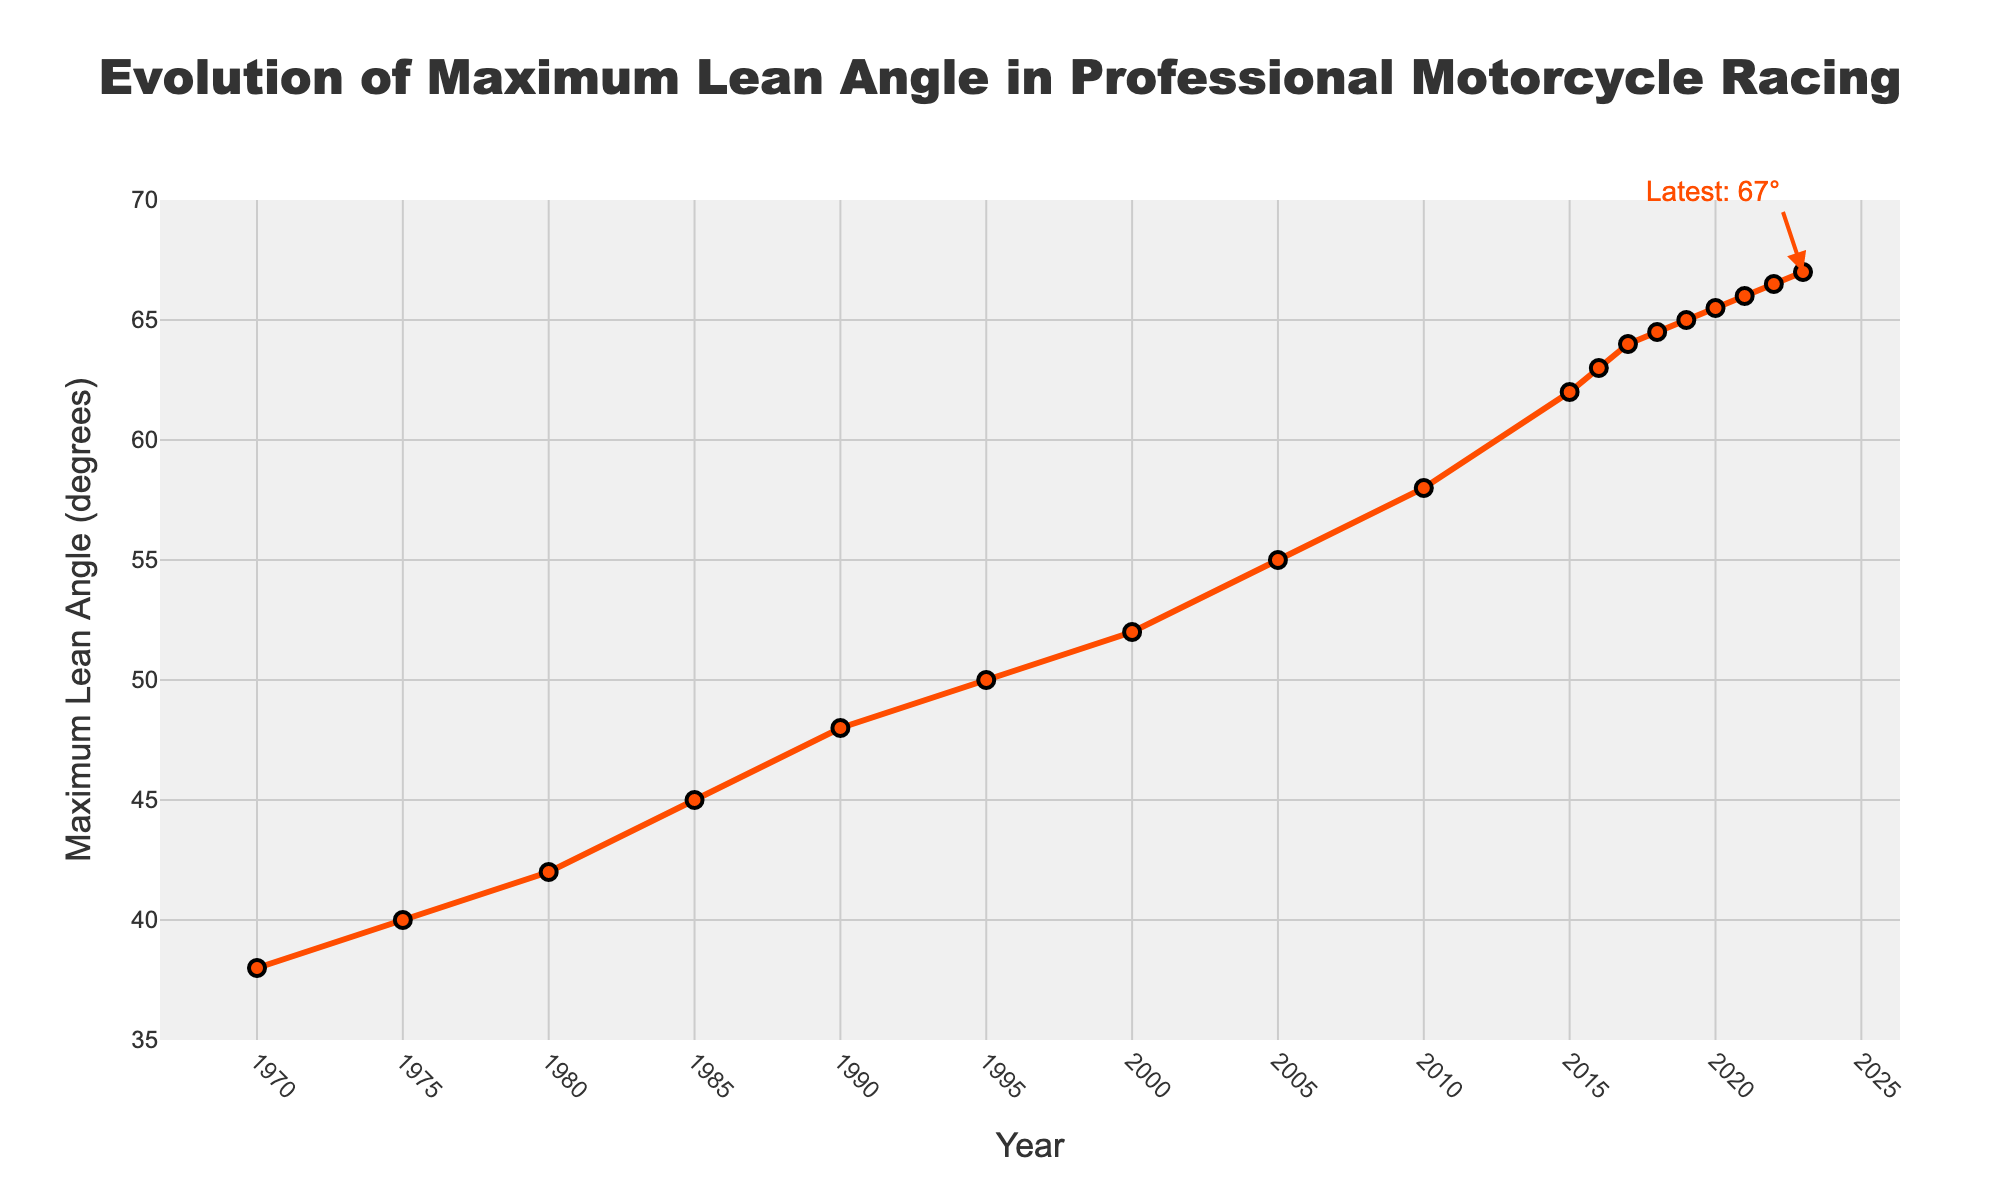What's the increase in maximum lean angle from 1980 to 2023? Observe the maximum lean angles in 1980 (42 degrees) and 2023 (67 degrees). Subtract the former from the latter: 67 - 42 = 25 degrees.
Answer: 25 degrees What was the maximum lean angle in 2010 compared to 1990? Look at the lean angles for 2010 (58 degrees) and 1990 (48 degrees). Compare the two values: 58 is greater than 48.
Answer: Greater in 2010 Between which consecutive years was the largest increase in maximum lean angle? Identify the years with noticeable increases. The biggest jump occurs between 2005 (55 degrees) and 2010 (58 degrees), which is a 3-degree increase.
Answer: 2005 and 2010 What is the average maximum lean angle from 2005 to 2015? Add the lean angles for 2005 (55 degrees), 2010 (58 degrees), and 2015 (62 degrees) and divide by the number of years. (55 + 58 + 62) / 3 = 58.33 degrees.
Answer: 58.33 degrees By how many degrees did the maximum lean angle increase from 1995 to 2022? Subtract the 1995 lean angle (50 degrees) from the 2022 lean angle (66.5 degrees): 66.5 - 50 = 16.5 degrees.
Answer: 16.5 degrees Which year had the smallest increase in maximum lean angle compared to the previous year? Calculate the year-to-year differences. From 2018 (64.5 degrees) to 2019 (65 degrees), the increase is only 0.5 degrees, which is the smallest.
Answer: 2019 In what year did the maximum lean angle first exceed 50 degrees? Pinpoint the first year over 50 degrees. It was 1995 with 50 degrees, so the first exceeding year was 2000 with 52 degrees.
Answer: 2000 What's the total increase in the maximum lean angle from 1970 to 2010? Identify the angles in 1970 (38 degrees) and 2010 (58 degrees). Subtract 38 from 58 to get the total increase: 58 - 38 = 20 degrees.
Answer: 20 degrees How does the 2023 maximum lean angle compare to the average maximum lean angle over the entire period? Calculate the average max lean over all years: sum = 808, number of years = 18. Average = 808 / 18 ≈ 44.89 degrees. Compare this to 2023's 67 degrees: 67 is much greater.
Answer: Much greater in 2023 